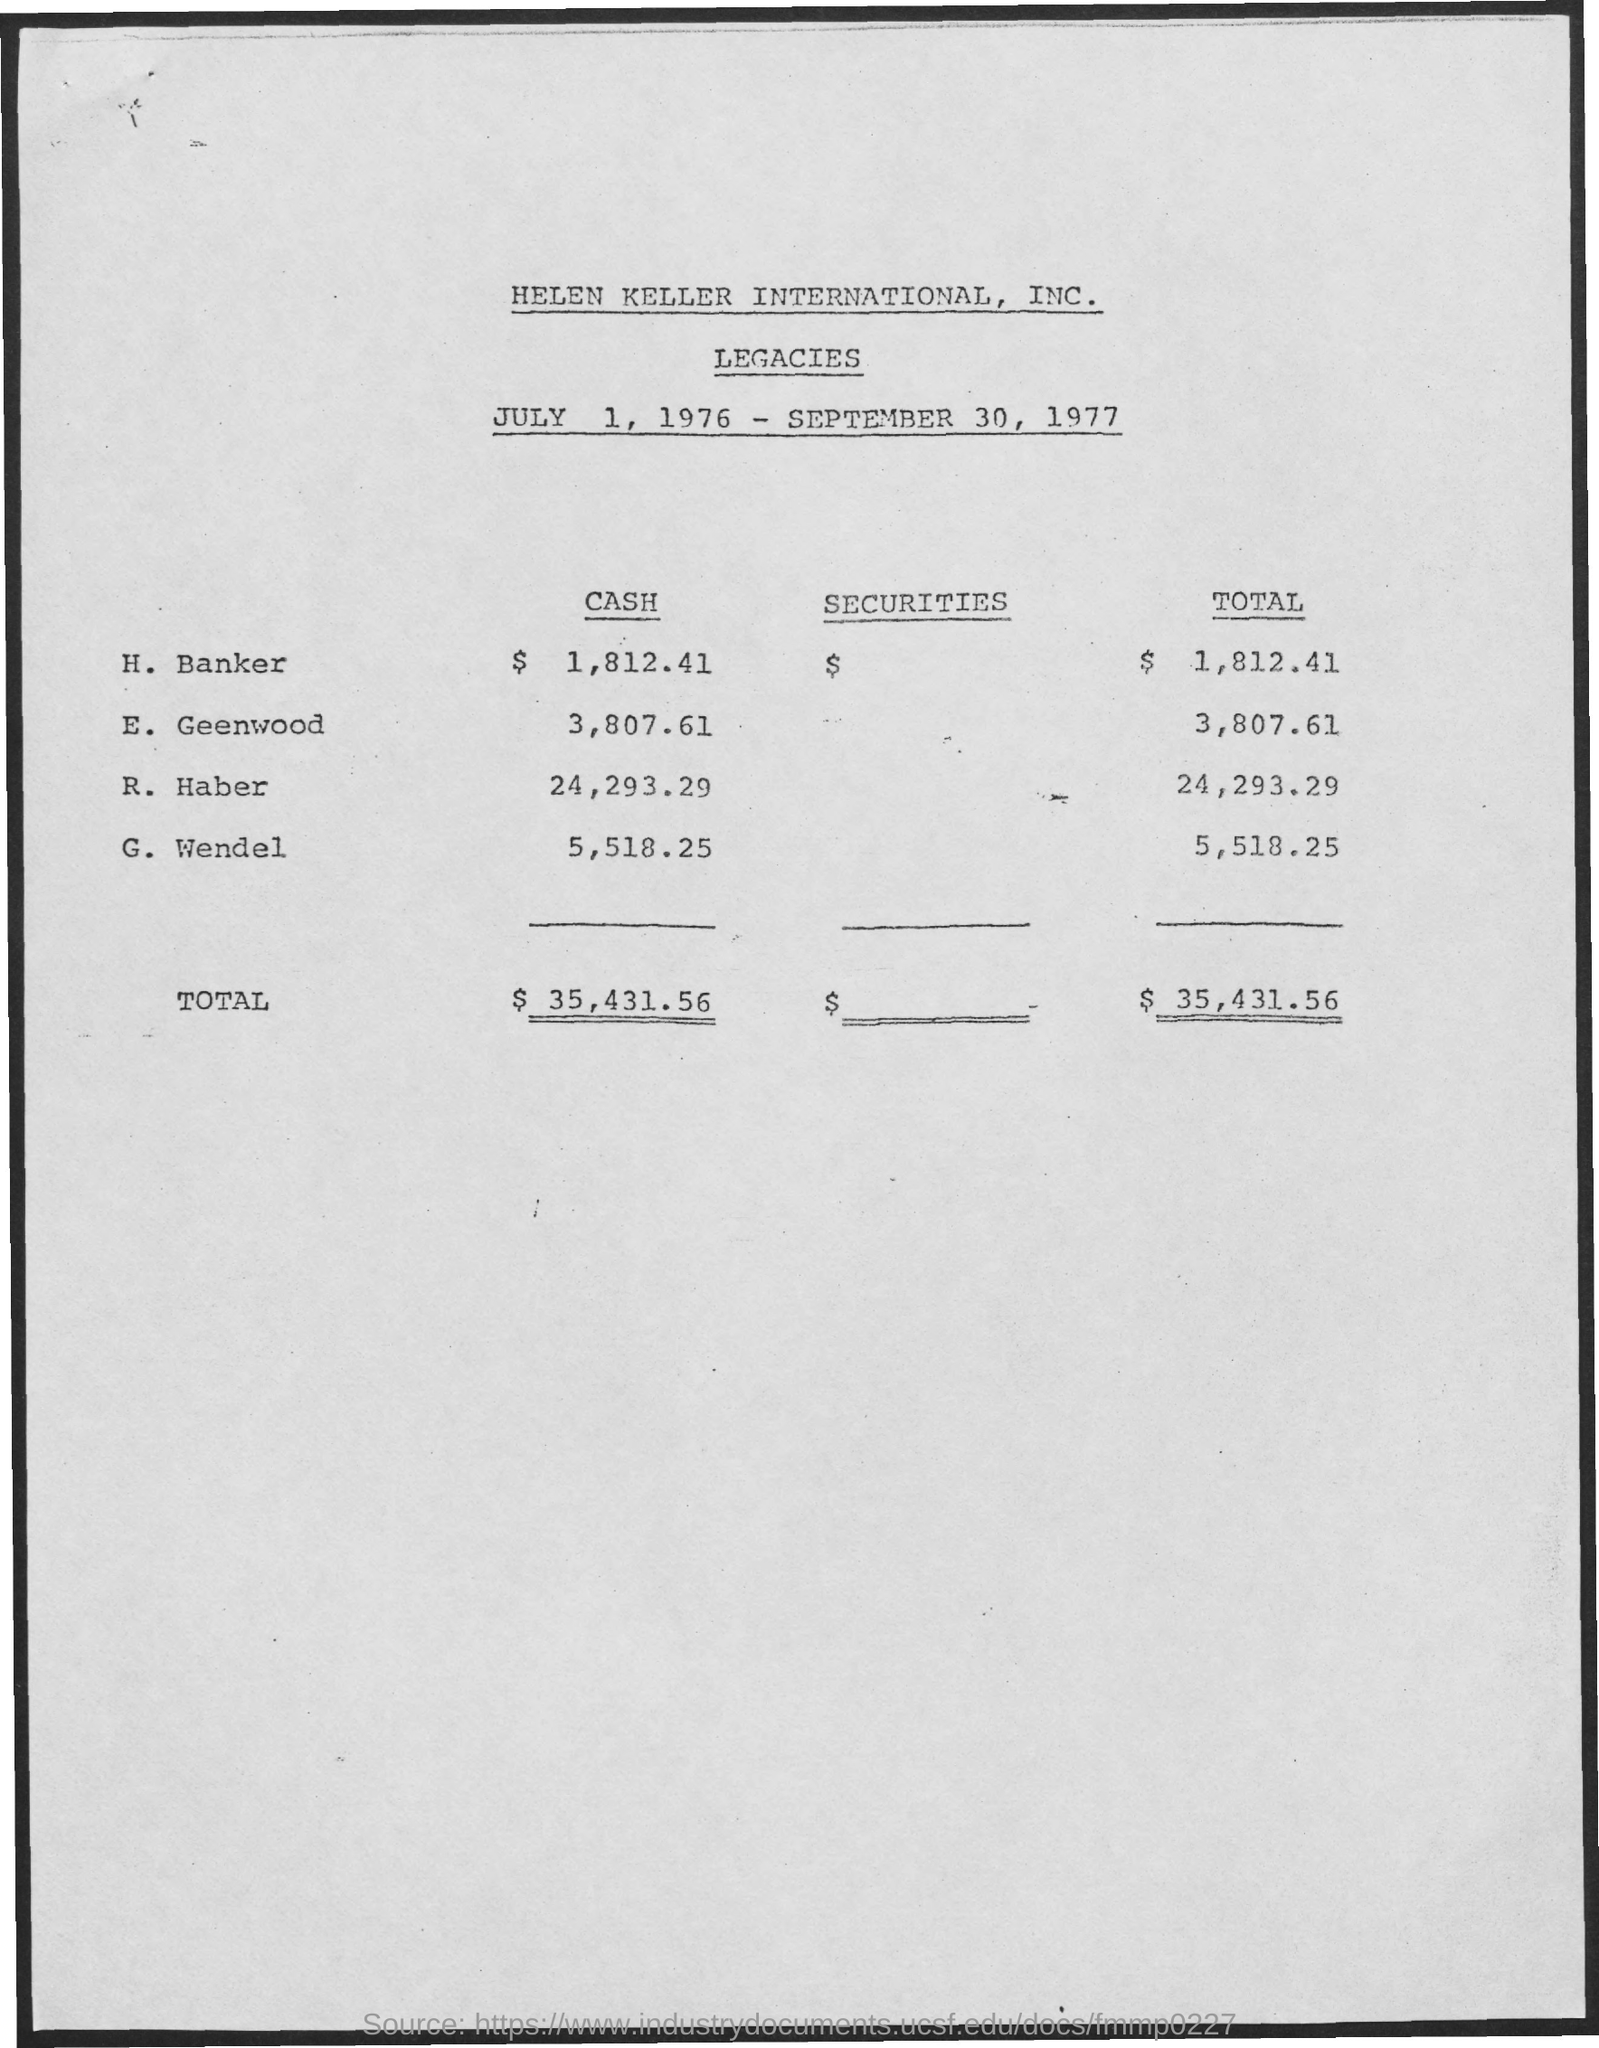What is the total of Haber?
Offer a very short reply. 24,293.29. 